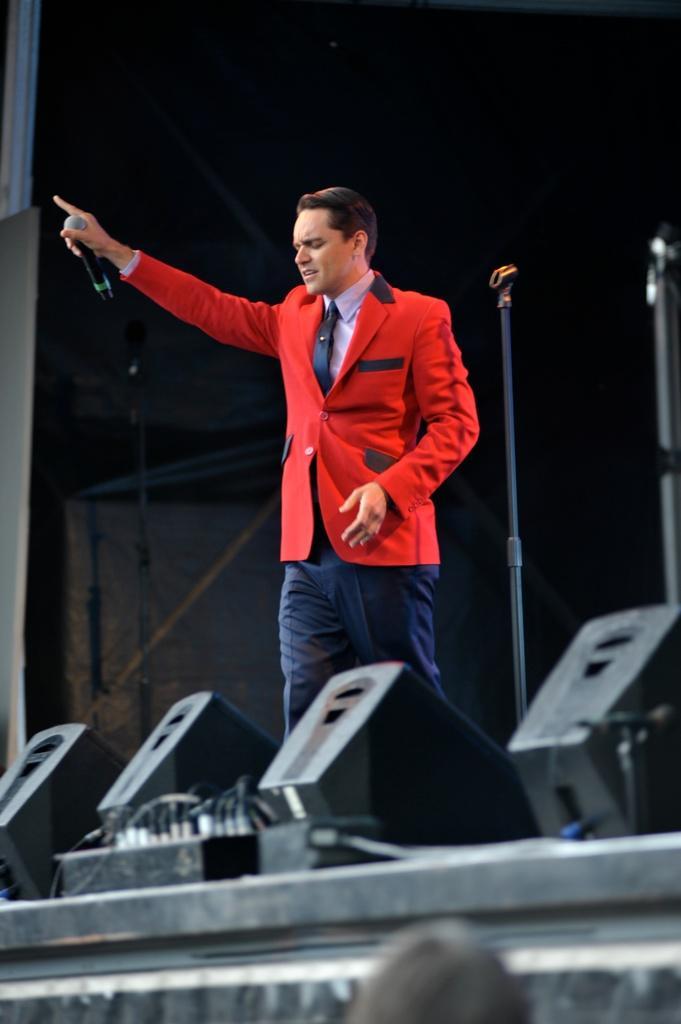How would you summarize this image in a sentence or two? In this image, we can see a man holding mic in his hand and in the background, there is a mic stand. At the bottom, there are lights. 